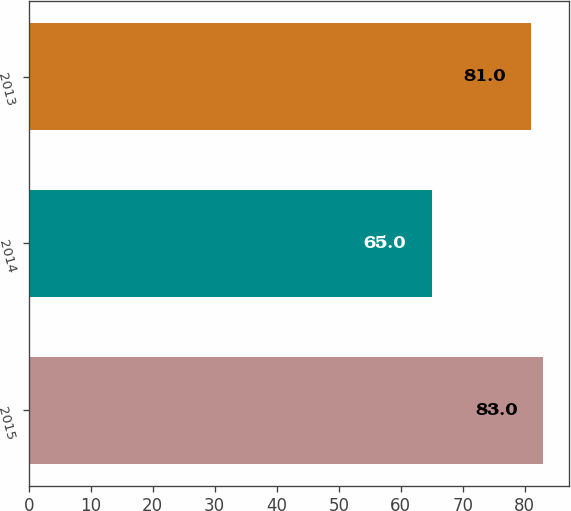Convert chart. <chart><loc_0><loc_0><loc_500><loc_500><bar_chart><fcel>2015<fcel>2014<fcel>2013<nl><fcel>83<fcel>65<fcel>81<nl></chart> 